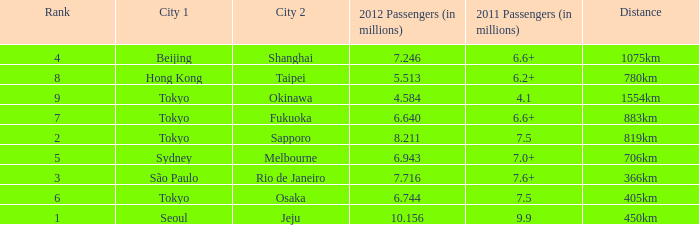Would you mind parsing the complete table? {'header': ['Rank', 'City 1', 'City 2', '2012 Passengers (in millions)', '2011 Passengers (in millions)', 'Distance'], 'rows': [['4', 'Beijing', 'Shanghai', '7.246', '6.6+', '1075km'], ['8', 'Hong Kong', 'Taipei', '5.513', '6.2+', '780km'], ['9', 'Tokyo', 'Okinawa', '4.584', '4.1', '1554km'], ['7', 'Tokyo', 'Fukuoka', '6.640', '6.6+', '883km'], ['2', 'Tokyo', 'Sapporo', '8.211', '7.5', '819km'], ['5', 'Sydney', 'Melbourne', '6.943', '7.0+', '706km'], ['3', 'São Paulo', 'Rio de Janeiro', '7.716', '7.6+', '366km'], ['6', 'Tokyo', 'Osaka', '6.744', '7.5', '405km'], ['1', 'Seoul', 'Jeju', '10.156', '9.9', '450km']]} In 2011, which city is listed first along the route that had 7.6+ million passengers? São Paulo. 